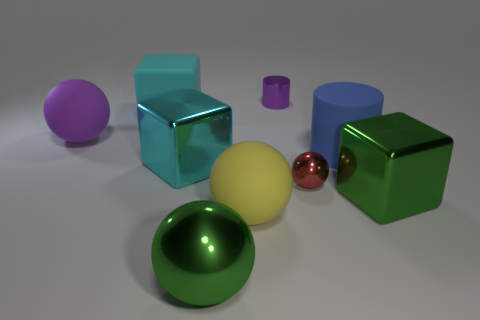Add 1 purple things. How many objects exist? 10 Subtract all cubes. How many objects are left? 6 Subtract all big gray cubes. Subtract all large green cubes. How many objects are left? 8 Add 4 green cubes. How many green cubes are left? 5 Add 7 red spheres. How many red spheres exist? 8 Subtract 0 gray blocks. How many objects are left? 9 